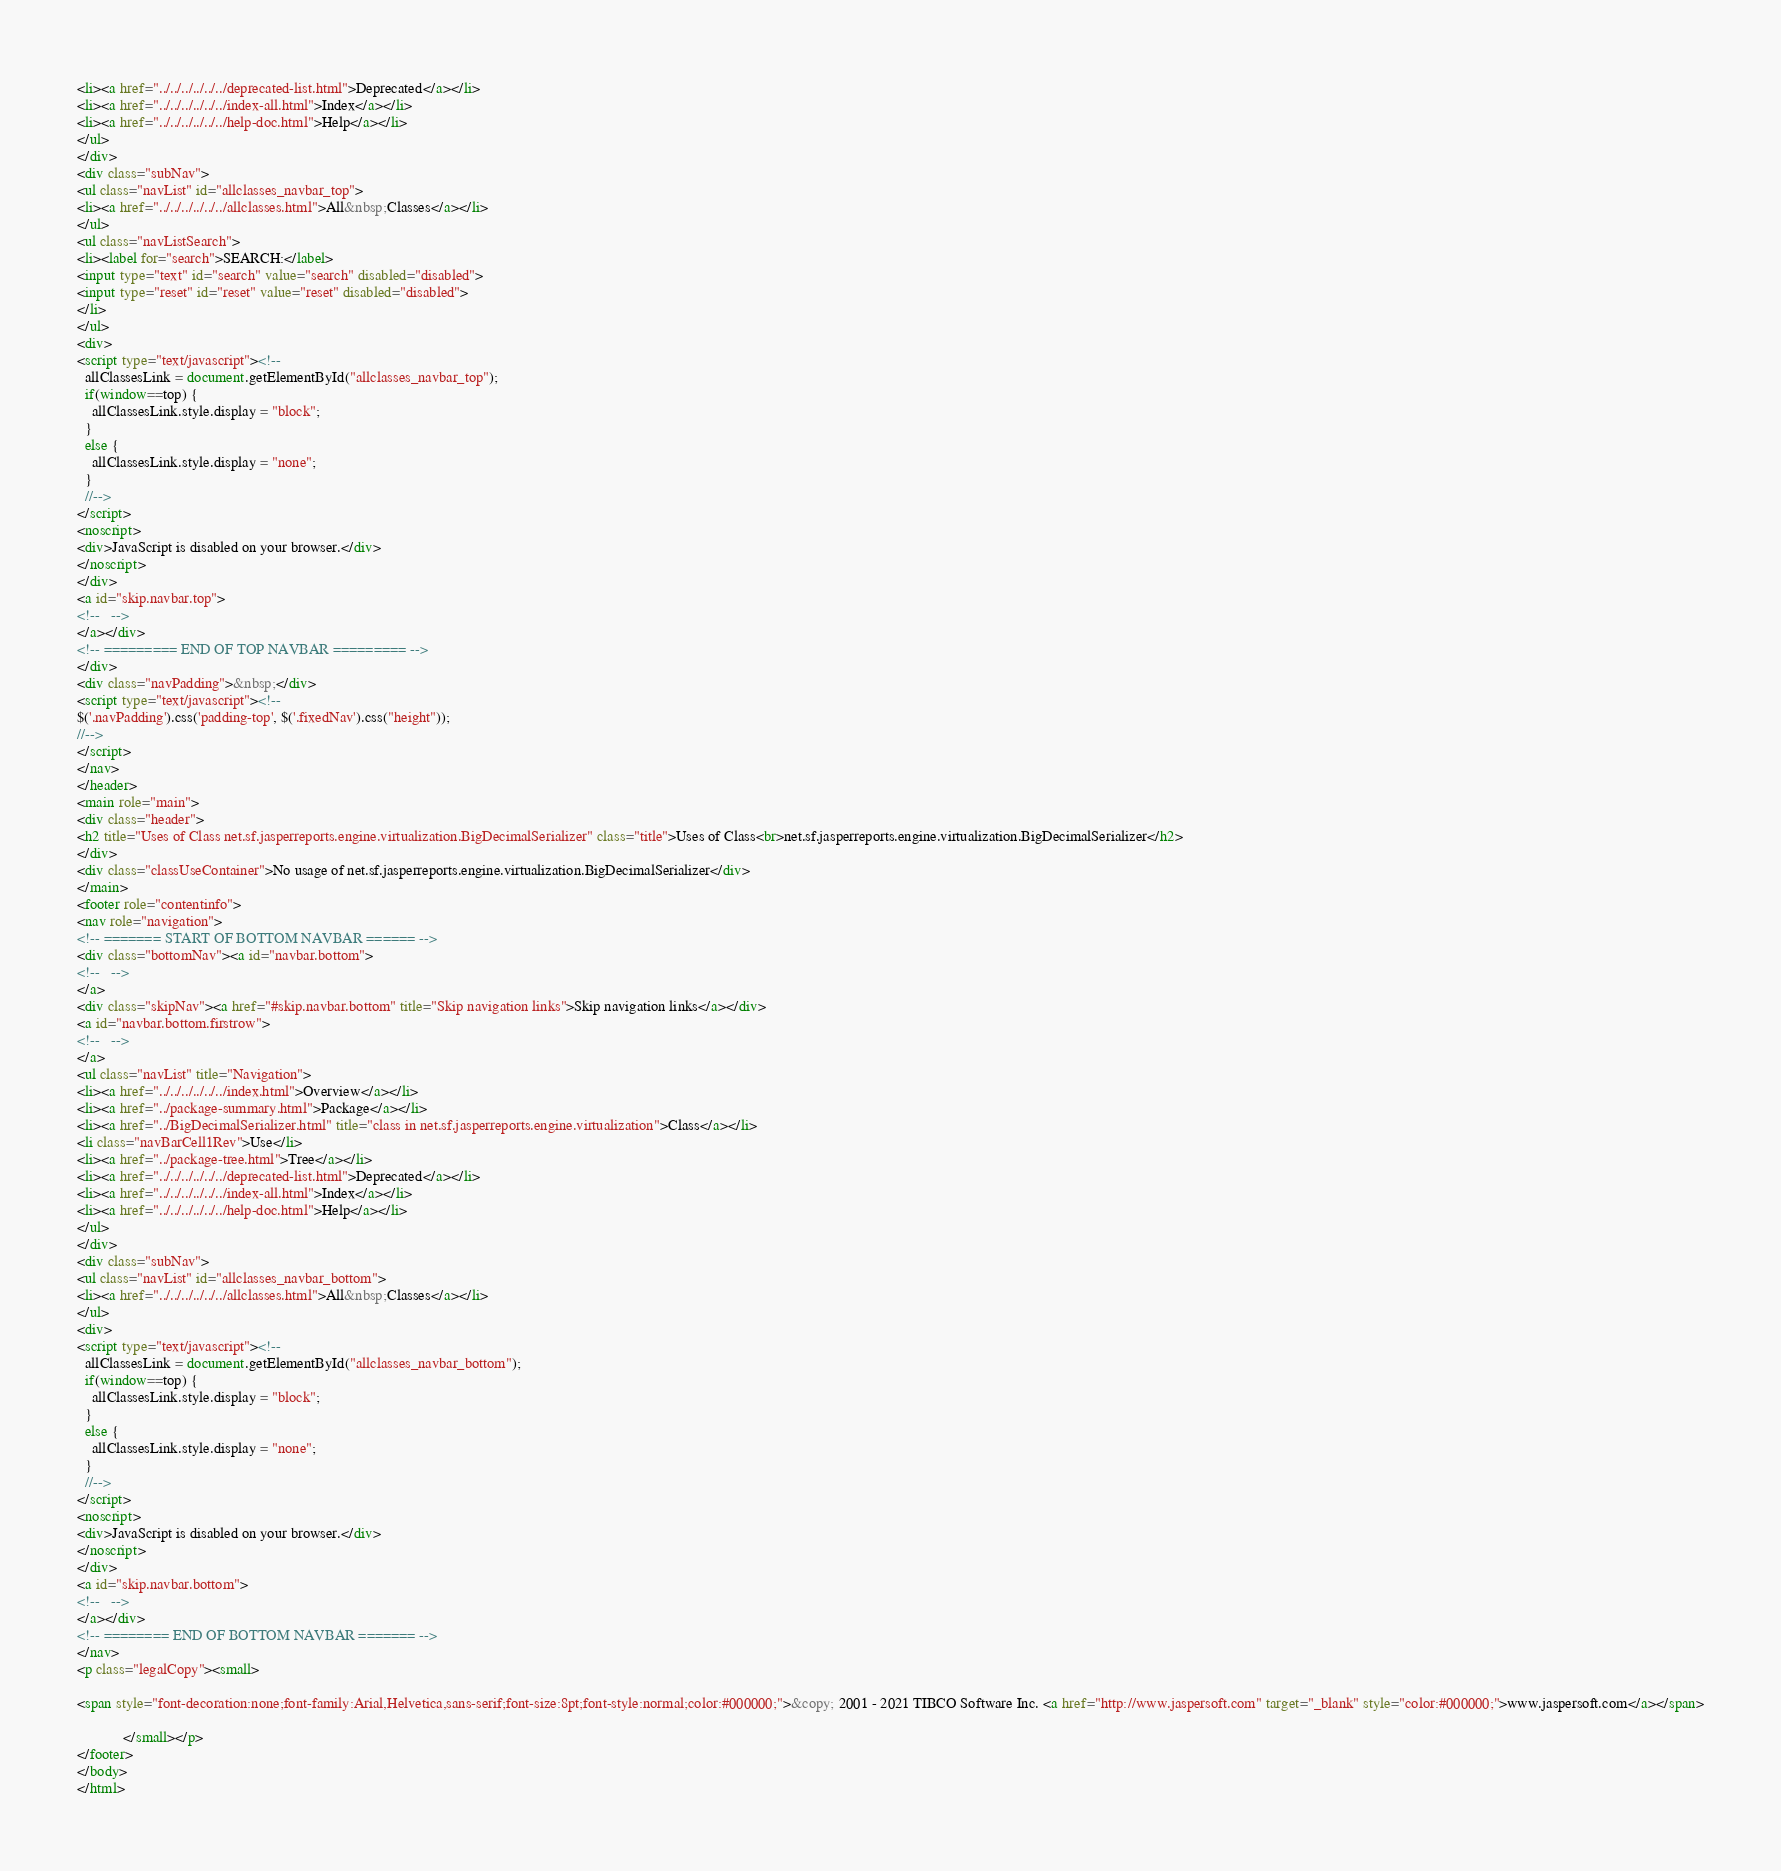Convert code to text. <code><loc_0><loc_0><loc_500><loc_500><_HTML_><li><a href="../../../../../../deprecated-list.html">Deprecated</a></li>
<li><a href="../../../../../../index-all.html">Index</a></li>
<li><a href="../../../../../../help-doc.html">Help</a></li>
</ul>
</div>
<div class="subNav">
<ul class="navList" id="allclasses_navbar_top">
<li><a href="../../../../../../allclasses.html">All&nbsp;Classes</a></li>
</ul>
<ul class="navListSearch">
<li><label for="search">SEARCH:</label>
<input type="text" id="search" value="search" disabled="disabled">
<input type="reset" id="reset" value="reset" disabled="disabled">
</li>
</ul>
<div>
<script type="text/javascript"><!--
  allClassesLink = document.getElementById("allclasses_navbar_top");
  if(window==top) {
    allClassesLink.style.display = "block";
  }
  else {
    allClassesLink.style.display = "none";
  }
  //-->
</script>
<noscript>
<div>JavaScript is disabled on your browser.</div>
</noscript>
</div>
<a id="skip.navbar.top">
<!--   -->
</a></div>
<!-- ========= END OF TOP NAVBAR ========= -->
</div>
<div class="navPadding">&nbsp;</div>
<script type="text/javascript"><!--
$('.navPadding').css('padding-top', $('.fixedNav').css("height"));
//-->
</script>
</nav>
</header>
<main role="main">
<div class="header">
<h2 title="Uses of Class net.sf.jasperreports.engine.virtualization.BigDecimalSerializer" class="title">Uses of Class<br>net.sf.jasperreports.engine.virtualization.BigDecimalSerializer</h2>
</div>
<div class="classUseContainer">No usage of net.sf.jasperreports.engine.virtualization.BigDecimalSerializer</div>
</main>
<footer role="contentinfo">
<nav role="navigation">
<!-- ======= START OF BOTTOM NAVBAR ====== -->
<div class="bottomNav"><a id="navbar.bottom">
<!--   -->
</a>
<div class="skipNav"><a href="#skip.navbar.bottom" title="Skip navigation links">Skip navigation links</a></div>
<a id="navbar.bottom.firstrow">
<!--   -->
</a>
<ul class="navList" title="Navigation">
<li><a href="../../../../../../index.html">Overview</a></li>
<li><a href="../package-summary.html">Package</a></li>
<li><a href="../BigDecimalSerializer.html" title="class in net.sf.jasperreports.engine.virtualization">Class</a></li>
<li class="navBarCell1Rev">Use</li>
<li><a href="../package-tree.html">Tree</a></li>
<li><a href="../../../../../../deprecated-list.html">Deprecated</a></li>
<li><a href="../../../../../../index-all.html">Index</a></li>
<li><a href="../../../../../../help-doc.html">Help</a></li>
</ul>
</div>
<div class="subNav">
<ul class="navList" id="allclasses_navbar_bottom">
<li><a href="../../../../../../allclasses.html">All&nbsp;Classes</a></li>
</ul>
<div>
<script type="text/javascript"><!--
  allClassesLink = document.getElementById("allclasses_navbar_bottom");
  if(window==top) {
    allClassesLink.style.display = "block";
  }
  else {
    allClassesLink.style.display = "none";
  }
  //-->
</script>
<noscript>
<div>JavaScript is disabled on your browser.</div>
</noscript>
</div>
<a id="skip.navbar.bottom">
<!--   -->
</a></div>
<!-- ======== END OF BOTTOM NAVBAR ======= -->
</nav>
<p class="legalCopy"><small>

<span style="font-decoration:none;font-family:Arial,Helvetica,sans-serif;font-size:8pt;font-style:normal;color:#000000;">&copy; 2001 - 2021 TIBCO Software Inc. <a href="http://www.jaspersoft.com" target="_blank" style="color:#000000;">www.jaspersoft.com</a></span>

			</small></p>
</footer>
</body>
</html>
</code> 